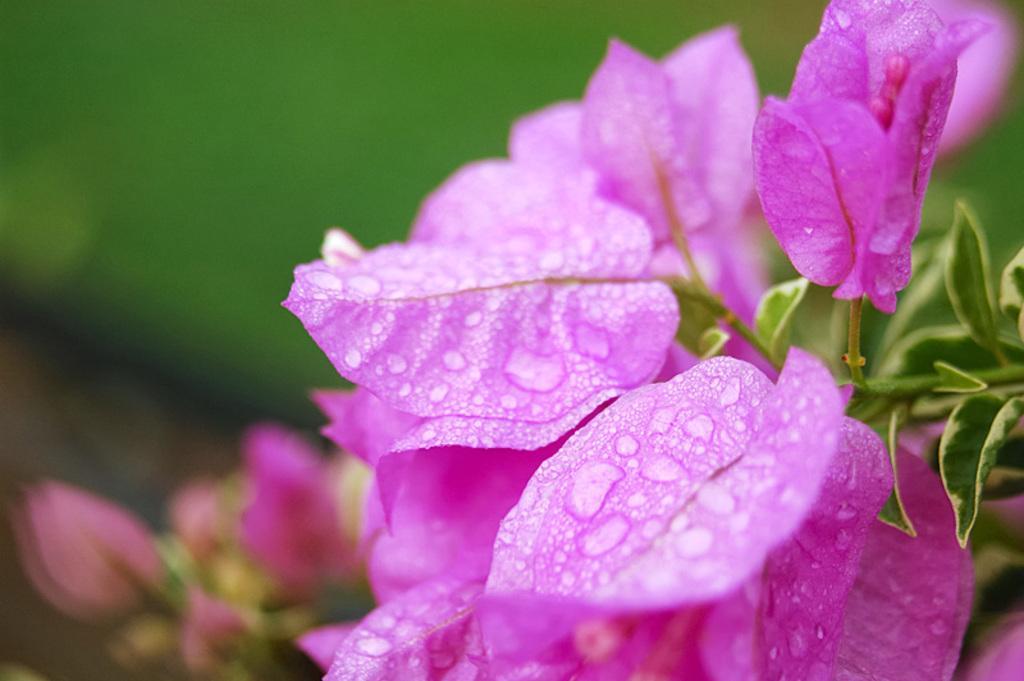Describe this image in one or two sentences. In this picture I can see the flowers which are of pink color and I see the water droplets and I can see few green color leaves. I see that it is totally blurred in the background. 